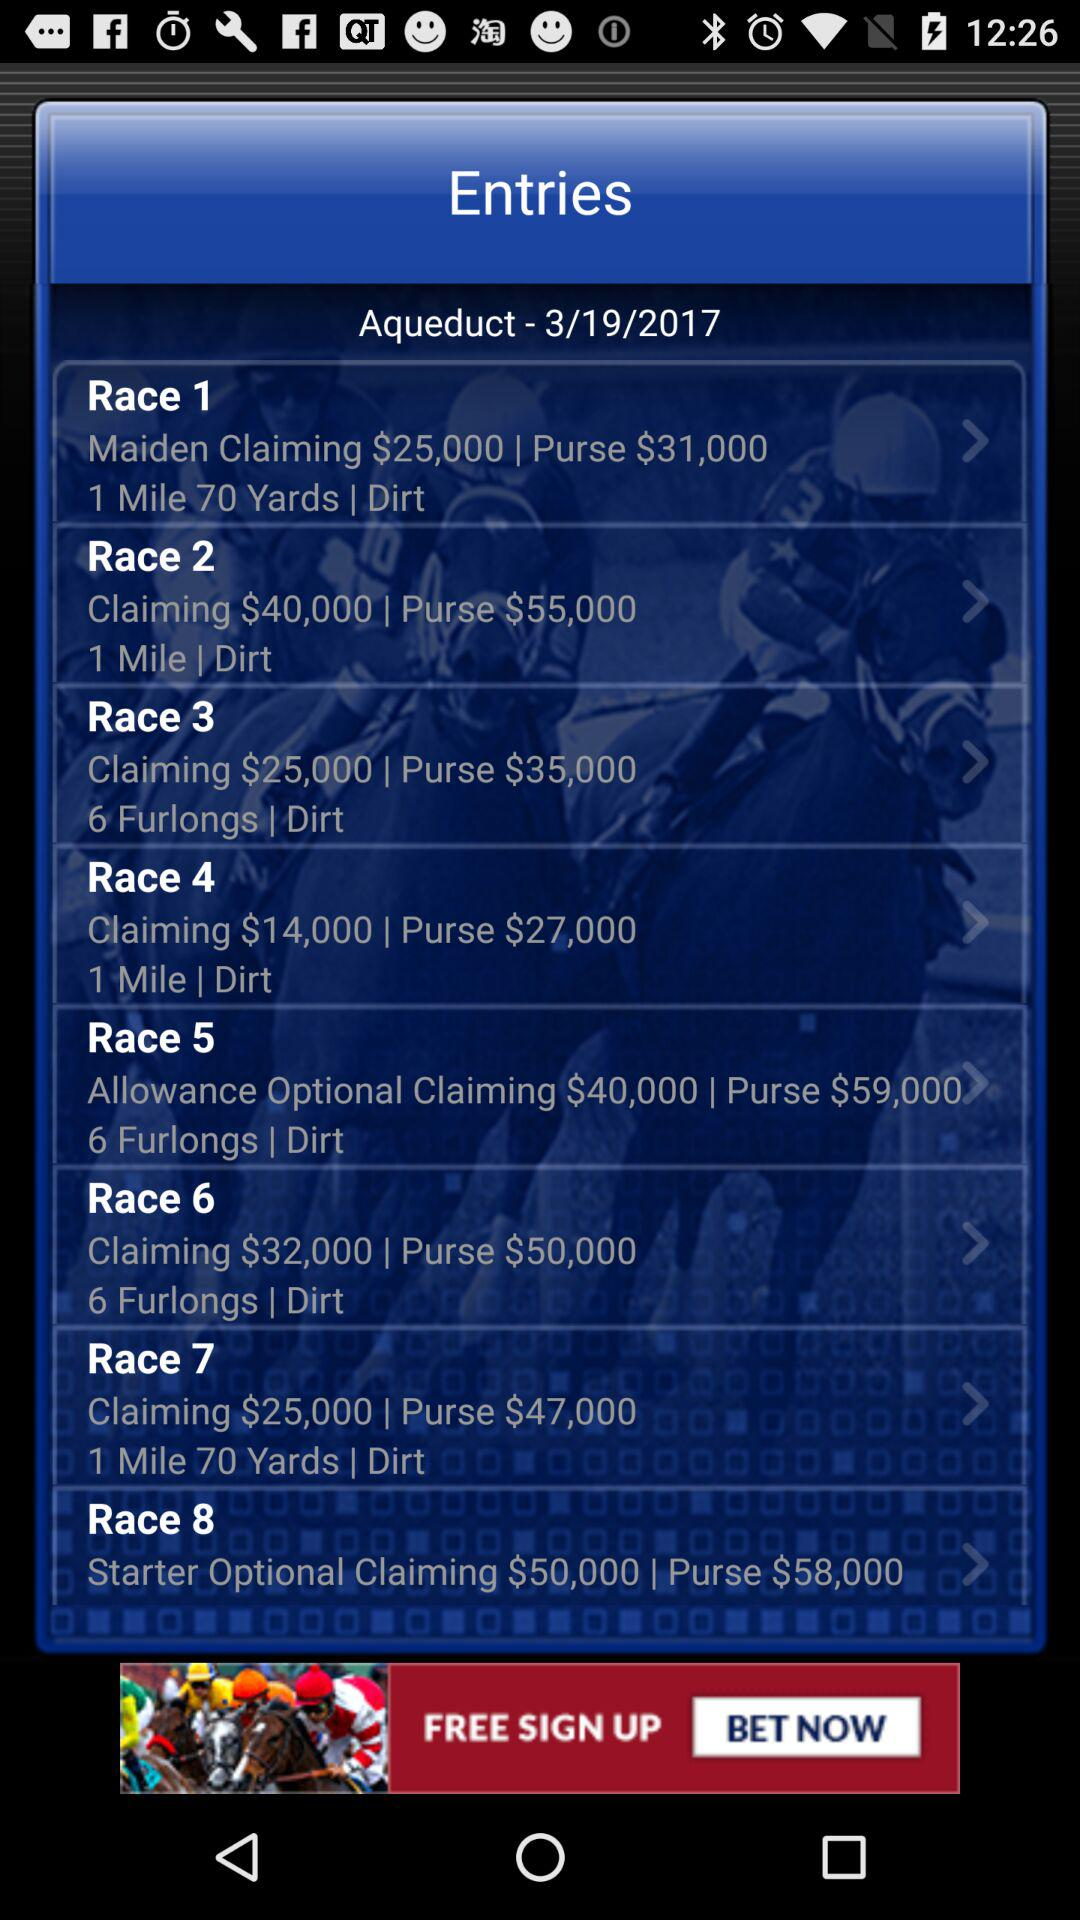What date is displayed on the screen? The date displayed on the screen is March 19, 2017. 